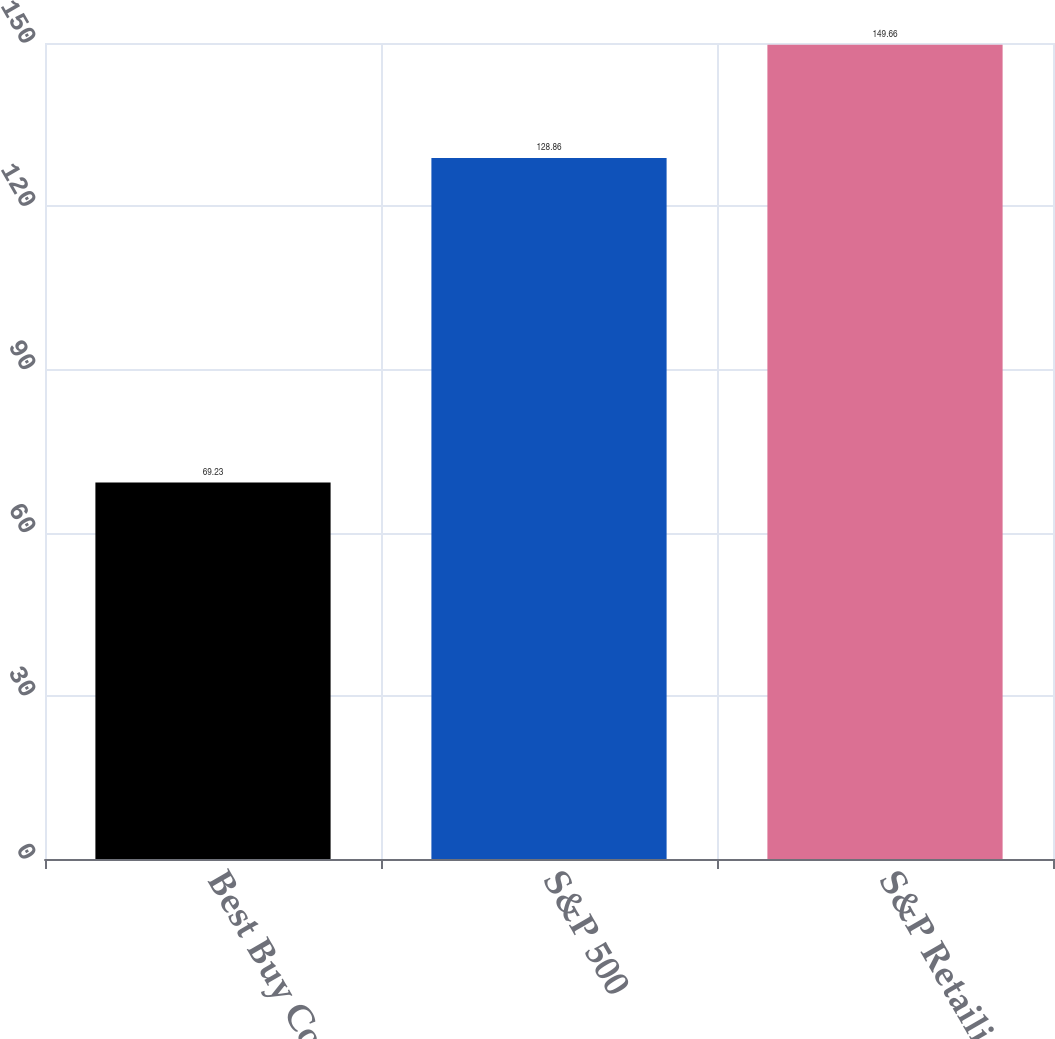<chart> <loc_0><loc_0><loc_500><loc_500><bar_chart><fcel>Best Buy Co Inc<fcel>S&P 500<fcel>S&P Retailing Group<nl><fcel>69.23<fcel>128.86<fcel>149.66<nl></chart> 